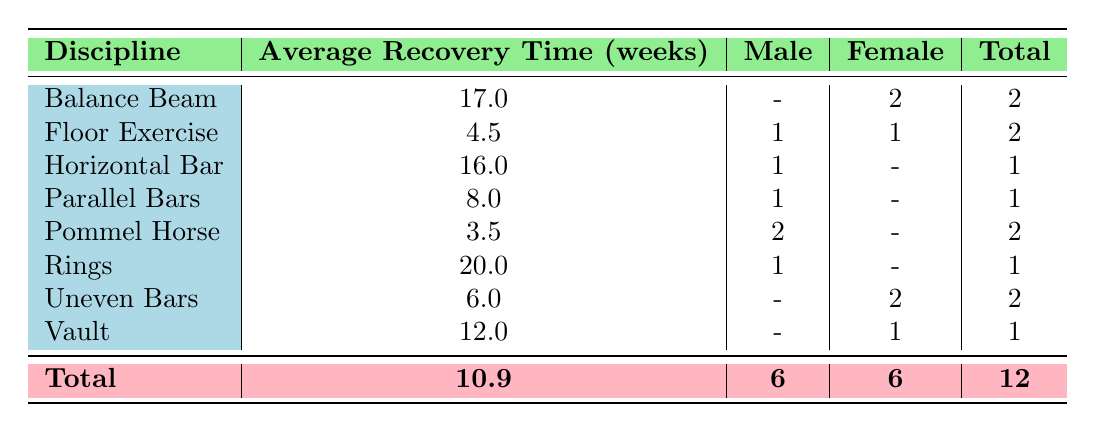What is the average recovery time for the Balance Beam discipline? The table indicates that the average recovery time for the Balance Beam discipline is listed at 17.0 weeks.
Answer: 17.0 How many male gymnasts have reported injuries in the Pommel Horse discipline? The table shows that there are 2 male gymnasts listed for the Pommel Horse discipline.
Answer: 2 What is the total recovery time for Female gymnasts across all disciplines? The total recovery time for Female gymnasts can be calculated by adding the recovery times: 24 (Balance Beam) + 8 (Uneven Bars) + 12 (Vault) + 3 (Floor Exercise) + 4 (Wrist Tendinitis) = 51 weeks.
Answer: 51 Is it true that the average recovery time for the Floor Exercise is less than 5 weeks? The average recovery time for the Floor Exercise is stated as 4.5 weeks, which is indeed less than 5 weeks. Therefore, the fact is true.
Answer: Yes What is the average recovery time for male gymnasts across all listed disciplines? The average recovery time for male gymnasts can be calculated as follows: (6 + 16 + 3 + 20) / 4 = 11.25 weeks. The recovery times for male gymnasts are 6 weeks (Floor Exercise), 16 weeks (Horizontal Bar), 3 weeks (Pommel Horse), and 20 weeks (Rings).
Answer: 11.25 How many total injuries were reported across all disciplines? The table indicates a total of 12 injuries, which is the total number of entries (one for each gymnast).
Answer: 12 What is the difference in average recovery time between female gymnasts and male gymnasts? To find the difference, we first calculate the average recovery times: Female average is (24 + 8 + 12 + 3 + 4) / 6 = 8.5 weeks and Male average is (6 + 16 + 3 + 20) / 6 = 11.25 weeks. The difference is 11.25 - 8.5 = 2.75 weeks.
Answer: 2.75 Are there any exercises where female gymnasts have reported severe injuries? Yes, the table lists that female gymnasts have reported severe injuries for the events of Vault and Balance Beam.
Answer: Yes What discipline has the highest average recovery time, and what is that time? The Ring discipline has the highest average recovery time, which is stated as 20.0 weeks in the table.
Answer: Rings, 20.0 